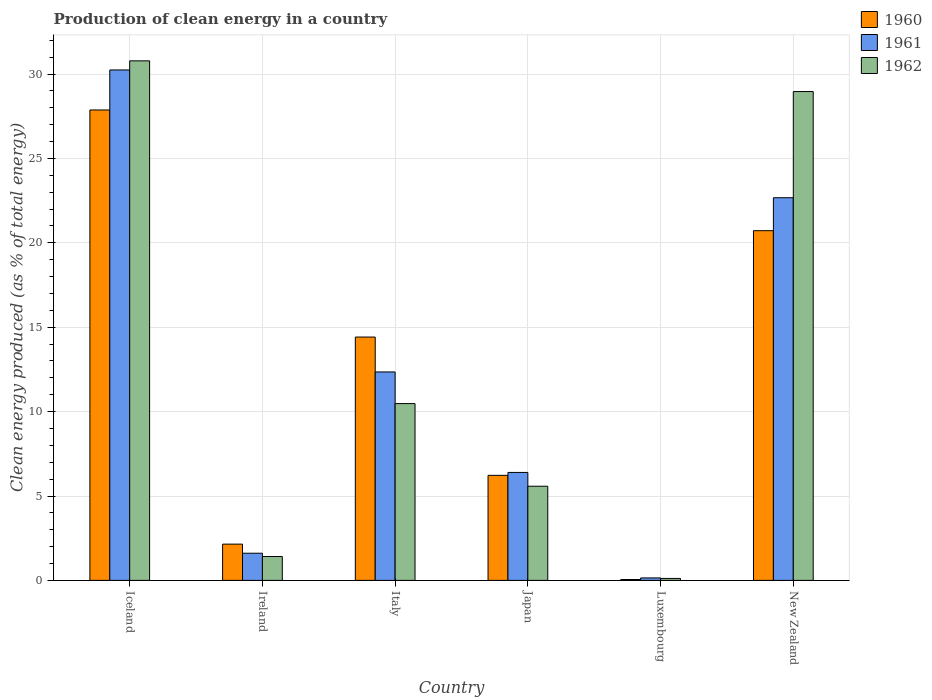How many groups of bars are there?
Provide a short and direct response. 6. Are the number of bars per tick equal to the number of legend labels?
Ensure brevity in your answer.  Yes. How many bars are there on the 4th tick from the left?
Provide a succinct answer. 3. What is the label of the 5th group of bars from the left?
Provide a short and direct response. Luxembourg. What is the percentage of clean energy produced in 1962 in Japan?
Offer a terse response. 5.58. Across all countries, what is the maximum percentage of clean energy produced in 1961?
Provide a succinct answer. 30.24. Across all countries, what is the minimum percentage of clean energy produced in 1960?
Your answer should be very brief. 0.05. In which country was the percentage of clean energy produced in 1960 maximum?
Provide a succinct answer. Iceland. In which country was the percentage of clean energy produced in 1960 minimum?
Keep it short and to the point. Luxembourg. What is the total percentage of clean energy produced in 1962 in the graph?
Your answer should be very brief. 77.33. What is the difference between the percentage of clean energy produced in 1962 in Luxembourg and that in New Zealand?
Provide a short and direct response. -28.85. What is the difference between the percentage of clean energy produced in 1961 in Iceland and the percentage of clean energy produced in 1962 in Ireland?
Ensure brevity in your answer.  28.83. What is the average percentage of clean energy produced in 1961 per country?
Provide a succinct answer. 12.24. What is the difference between the percentage of clean energy produced of/in 1960 and percentage of clean energy produced of/in 1961 in Italy?
Ensure brevity in your answer.  2.07. What is the ratio of the percentage of clean energy produced in 1960 in Ireland to that in Luxembourg?
Provide a short and direct response. 41.27. What is the difference between the highest and the second highest percentage of clean energy produced in 1960?
Make the answer very short. 7.15. What is the difference between the highest and the lowest percentage of clean energy produced in 1962?
Provide a short and direct response. 30.67. What does the 2nd bar from the left in Italy represents?
Provide a short and direct response. 1961. Are all the bars in the graph horizontal?
Make the answer very short. No. How many countries are there in the graph?
Offer a very short reply. 6. Does the graph contain grids?
Provide a short and direct response. Yes. Where does the legend appear in the graph?
Your answer should be compact. Top right. What is the title of the graph?
Ensure brevity in your answer.  Production of clean energy in a country. What is the label or title of the X-axis?
Ensure brevity in your answer.  Country. What is the label or title of the Y-axis?
Give a very brief answer. Clean energy produced (as % of total energy). What is the Clean energy produced (as % of total energy) of 1960 in Iceland?
Make the answer very short. 27.87. What is the Clean energy produced (as % of total energy) in 1961 in Iceland?
Your answer should be very brief. 30.24. What is the Clean energy produced (as % of total energy) in 1962 in Iceland?
Offer a very short reply. 30.78. What is the Clean energy produced (as % of total energy) in 1960 in Ireland?
Provide a succinct answer. 2.15. What is the Clean energy produced (as % of total energy) in 1961 in Ireland?
Make the answer very short. 1.61. What is the Clean energy produced (as % of total energy) of 1962 in Ireland?
Offer a very short reply. 1.41. What is the Clean energy produced (as % of total energy) in 1960 in Italy?
Provide a succinct answer. 14.42. What is the Clean energy produced (as % of total energy) in 1961 in Italy?
Provide a succinct answer. 12.35. What is the Clean energy produced (as % of total energy) of 1962 in Italy?
Provide a short and direct response. 10.48. What is the Clean energy produced (as % of total energy) in 1960 in Japan?
Your response must be concise. 6.22. What is the Clean energy produced (as % of total energy) in 1961 in Japan?
Keep it short and to the point. 6.4. What is the Clean energy produced (as % of total energy) in 1962 in Japan?
Make the answer very short. 5.58. What is the Clean energy produced (as % of total energy) of 1960 in Luxembourg?
Your answer should be compact. 0.05. What is the Clean energy produced (as % of total energy) in 1961 in Luxembourg?
Keep it short and to the point. 0.15. What is the Clean energy produced (as % of total energy) of 1962 in Luxembourg?
Your response must be concise. 0.12. What is the Clean energy produced (as % of total energy) of 1960 in New Zealand?
Ensure brevity in your answer.  20.72. What is the Clean energy produced (as % of total energy) of 1961 in New Zealand?
Offer a terse response. 22.67. What is the Clean energy produced (as % of total energy) in 1962 in New Zealand?
Offer a terse response. 28.96. Across all countries, what is the maximum Clean energy produced (as % of total energy) of 1960?
Offer a terse response. 27.87. Across all countries, what is the maximum Clean energy produced (as % of total energy) in 1961?
Keep it short and to the point. 30.24. Across all countries, what is the maximum Clean energy produced (as % of total energy) in 1962?
Provide a short and direct response. 30.78. Across all countries, what is the minimum Clean energy produced (as % of total energy) of 1960?
Your response must be concise. 0.05. Across all countries, what is the minimum Clean energy produced (as % of total energy) in 1961?
Make the answer very short. 0.15. Across all countries, what is the minimum Clean energy produced (as % of total energy) of 1962?
Keep it short and to the point. 0.12. What is the total Clean energy produced (as % of total energy) of 1960 in the graph?
Offer a terse response. 71.43. What is the total Clean energy produced (as % of total energy) of 1961 in the graph?
Your answer should be compact. 73.42. What is the total Clean energy produced (as % of total energy) in 1962 in the graph?
Your response must be concise. 77.33. What is the difference between the Clean energy produced (as % of total energy) of 1960 in Iceland and that in Ireland?
Make the answer very short. 25.72. What is the difference between the Clean energy produced (as % of total energy) of 1961 in Iceland and that in Ireland?
Offer a very short reply. 28.63. What is the difference between the Clean energy produced (as % of total energy) of 1962 in Iceland and that in Ireland?
Provide a short and direct response. 29.37. What is the difference between the Clean energy produced (as % of total energy) in 1960 in Iceland and that in Italy?
Make the answer very short. 13.46. What is the difference between the Clean energy produced (as % of total energy) in 1961 in Iceland and that in Italy?
Give a very brief answer. 17.89. What is the difference between the Clean energy produced (as % of total energy) in 1962 in Iceland and that in Italy?
Keep it short and to the point. 20.31. What is the difference between the Clean energy produced (as % of total energy) in 1960 in Iceland and that in Japan?
Your answer should be very brief. 21.65. What is the difference between the Clean energy produced (as % of total energy) of 1961 in Iceland and that in Japan?
Make the answer very short. 23.85. What is the difference between the Clean energy produced (as % of total energy) of 1962 in Iceland and that in Japan?
Your answer should be very brief. 25.2. What is the difference between the Clean energy produced (as % of total energy) in 1960 in Iceland and that in Luxembourg?
Offer a terse response. 27.82. What is the difference between the Clean energy produced (as % of total energy) of 1961 in Iceland and that in Luxembourg?
Your answer should be compact. 30.1. What is the difference between the Clean energy produced (as % of total energy) of 1962 in Iceland and that in Luxembourg?
Your answer should be very brief. 30.67. What is the difference between the Clean energy produced (as % of total energy) in 1960 in Iceland and that in New Zealand?
Provide a succinct answer. 7.15. What is the difference between the Clean energy produced (as % of total energy) of 1961 in Iceland and that in New Zealand?
Your response must be concise. 7.57. What is the difference between the Clean energy produced (as % of total energy) in 1962 in Iceland and that in New Zealand?
Provide a short and direct response. 1.82. What is the difference between the Clean energy produced (as % of total energy) of 1960 in Ireland and that in Italy?
Offer a very short reply. -12.27. What is the difference between the Clean energy produced (as % of total energy) in 1961 in Ireland and that in Italy?
Give a very brief answer. -10.74. What is the difference between the Clean energy produced (as % of total energy) in 1962 in Ireland and that in Italy?
Ensure brevity in your answer.  -9.06. What is the difference between the Clean energy produced (as % of total energy) in 1960 in Ireland and that in Japan?
Your answer should be compact. -4.08. What is the difference between the Clean energy produced (as % of total energy) of 1961 in Ireland and that in Japan?
Make the answer very short. -4.79. What is the difference between the Clean energy produced (as % of total energy) in 1962 in Ireland and that in Japan?
Give a very brief answer. -4.16. What is the difference between the Clean energy produced (as % of total energy) in 1960 in Ireland and that in Luxembourg?
Your response must be concise. 2.1. What is the difference between the Clean energy produced (as % of total energy) in 1961 in Ireland and that in Luxembourg?
Keep it short and to the point. 1.46. What is the difference between the Clean energy produced (as % of total energy) in 1962 in Ireland and that in Luxembourg?
Your answer should be compact. 1.3. What is the difference between the Clean energy produced (as % of total energy) in 1960 in Ireland and that in New Zealand?
Offer a very short reply. -18.57. What is the difference between the Clean energy produced (as % of total energy) of 1961 in Ireland and that in New Zealand?
Your response must be concise. -21.06. What is the difference between the Clean energy produced (as % of total energy) in 1962 in Ireland and that in New Zealand?
Your answer should be compact. -27.55. What is the difference between the Clean energy produced (as % of total energy) in 1960 in Italy and that in Japan?
Offer a terse response. 8.19. What is the difference between the Clean energy produced (as % of total energy) in 1961 in Italy and that in Japan?
Provide a succinct answer. 5.95. What is the difference between the Clean energy produced (as % of total energy) in 1962 in Italy and that in Japan?
Your answer should be compact. 4.9. What is the difference between the Clean energy produced (as % of total energy) of 1960 in Italy and that in Luxembourg?
Your answer should be very brief. 14.37. What is the difference between the Clean energy produced (as % of total energy) in 1961 in Italy and that in Luxembourg?
Give a very brief answer. 12.2. What is the difference between the Clean energy produced (as % of total energy) of 1962 in Italy and that in Luxembourg?
Your response must be concise. 10.36. What is the difference between the Clean energy produced (as % of total energy) in 1960 in Italy and that in New Zealand?
Your answer should be very brief. -6.3. What is the difference between the Clean energy produced (as % of total energy) in 1961 in Italy and that in New Zealand?
Keep it short and to the point. -10.32. What is the difference between the Clean energy produced (as % of total energy) of 1962 in Italy and that in New Zealand?
Give a very brief answer. -18.49. What is the difference between the Clean energy produced (as % of total energy) of 1960 in Japan and that in Luxembourg?
Offer a terse response. 6.17. What is the difference between the Clean energy produced (as % of total energy) of 1961 in Japan and that in Luxembourg?
Offer a very short reply. 6.25. What is the difference between the Clean energy produced (as % of total energy) of 1962 in Japan and that in Luxembourg?
Offer a very short reply. 5.46. What is the difference between the Clean energy produced (as % of total energy) in 1960 in Japan and that in New Zealand?
Offer a terse response. -14.5. What is the difference between the Clean energy produced (as % of total energy) of 1961 in Japan and that in New Zealand?
Keep it short and to the point. -16.28. What is the difference between the Clean energy produced (as % of total energy) in 1962 in Japan and that in New Zealand?
Provide a short and direct response. -23.38. What is the difference between the Clean energy produced (as % of total energy) in 1960 in Luxembourg and that in New Zealand?
Provide a short and direct response. -20.67. What is the difference between the Clean energy produced (as % of total energy) in 1961 in Luxembourg and that in New Zealand?
Your answer should be compact. -22.53. What is the difference between the Clean energy produced (as % of total energy) of 1962 in Luxembourg and that in New Zealand?
Your answer should be very brief. -28.85. What is the difference between the Clean energy produced (as % of total energy) of 1960 in Iceland and the Clean energy produced (as % of total energy) of 1961 in Ireland?
Your answer should be compact. 26.26. What is the difference between the Clean energy produced (as % of total energy) in 1960 in Iceland and the Clean energy produced (as % of total energy) in 1962 in Ireland?
Provide a short and direct response. 26.46. What is the difference between the Clean energy produced (as % of total energy) in 1961 in Iceland and the Clean energy produced (as % of total energy) in 1962 in Ireland?
Offer a very short reply. 28.83. What is the difference between the Clean energy produced (as % of total energy) of 1960 in Iceland and the Clean energy produced (as % of total energy) of 1961 in Italy?
Ensure brevity in your answer.  15.52. What is the difference between the Clean energy produced (as % of total energy) of 1960 in Iceland and the Clean energy produced (as % of total energy) of 1962 in Italy?
Provide a short and direct response. 17.4. What is the difference between the Clean energy produced (as % of total energy) of 1961 in Iceland and the Clean energy produced (as % of total energy) of 1962 in Italy?
Your answer should be compact. 19.77. What is the difference between the Clean energy produced (as % of total energy) in 1960 in Iceland and the Clean energy produced (as % of total energy) in 1961 in Japan?
Your answer should be very brief. 21.48. What is the difference between the Clean energy produced (as % of total energy) of 1960 in Iceland and the Clean energy produced (as % of total energy) of 1962 in Japan?
Ensure brevity in your answer.  22.29. What is the difference between the Clean energy produced (as % of total energy) in 1961 in Iceland and the Clean energy produced (as % of total energy) in 1962 in Japan?
Make the answer very short. 24.66. What is the difference between the Clean energy produced (as % of total energy) in 1960 in Iceland and the Clean energy produced (as % of total energy) in 1961 in Luxembourg?
Provide a succinct answer. 27.73. What is the difference between the Clean energy produced (as % of total energy) of 1960 in Iceland and the Clean energy produced (as % of total energy) of 1962 in Luxembourg?
Provide a short and direct response. 27.76. What is the difference between the Clean energy produced (as % of total energy) of 1961 in Iceland and the Clean energy produced (as % of total energy) of 1962 in Luxembourg?
Provide a short and direct response. 30.13. What is the difference between the Clean energy produced (as % of total energy) of 1960 in Iceland and the Clean energy produced (as % of total energy) of 1961 in New Zealand?
Your answer should be compact. 5.2. What is the difference between the Clean energy produced (as % of total energy) of 1960 in Iceland and the Clean energy produced (as % of total energy) of 1962 in New Zealand?
Make the answer very short. -1.09. What is the difference between the Clean energy produced (as % of total energy) of 1961 in Iceland and the Clean energy produced (as % of total energy) of 1962 in New Zealand?
Provide a succinct answer. 1.28. What is the difference between the Clean energy produced (as % of total energy) in 1960 in Ireland and the Clean energy produced (as % of total energy) in 1961 in Italy?
Make the answer very short. -10.2. What is the difference between the Clean energy produced (as % of total energy) in 1960 in Ireland and the Clean energy produced (as % of total energy) in 1962 in Italy?
Your answer should be very brief. -8.33. What is the difference between the Clean energy produced (as % of total energy) of 1961 in Ireland and the Clean energy produced (as % of total energy) of 1962 in Italy?
Your answer should be very brief. -8.87. What is the difference between the Clean energy produced (as % of total energy) in 1960 in Ireland and the Clean energy produced (as % of total energy) in 1961 in Japan?
Offer a very short reply. -4.25. What is the difference between the Clean energy produced (as % of total energy) in 1960 in Ireland and the Clean energy produced (as % of total energy) in 1962 in Japan?
Offer a terse response. -3.43. What is the difference between the Clean energy produced (as % of total energy) of 1961 in Ireland and the Clean energy produced (as % of total energy) of 1962 in Japan?
Your response must be concise. -3.97. What is the difference between the Clean energy produced (as % of total energy) of 1960 in Ireland and the Clean energy produced (as % of total energy) of 1961 in Luxembourg?
Make the answer very short. 2. What is the difference between the Clean energy produced (as % of total energy) of 1960 in Ireland and the Clean energy produced (as % of total energy) of 1962 in Luxembourg?
Offer a terse response. 2.03. What is the difference between the Clean energy produced (as % of total energy) of 1961 in Ireland and the Clean energy produced (as % of total energy) of 1962 in Luxembourg?
Provide a short and direct response. 1.49. What is the difference between the Clean energy produced (as % of total energy) in 1960 in Ireland and the Clean energy produced (as % of total energy) in 1961 in New Zealand?
Keep it short and to the point. -20.52. What is the difference between the Clean energy produced (as % of total energy) of 1960 in Ireland and the Clean energy produced (as % of total energy) of 1962 in New Zealand?
Make the answer very short. -26.82. What is the difference between the Clean energy produced (as % of total energy) of 1961 in Ireland and the Clean energy produced (as % of total energy) of 1962 in New Zealand?
Provide a short and direct response. -27.35. What is the difference between the Clean energy produced (as % of total energy) of 1960 in Italy and the Clean energy produced (as % of total energy) of 1961 in Japan?
Your answer should be compact. 8.02. What is the difference between the Clean energy produced (as % of total energy) in 1960 in Italy and the Clean energy produced (as % of total energy) in 1962 in Japan?
Offer a very short reply. 8.84. What is the difference between the Clean energy produced (as % of total energy) of 1961 in Italy and the Clean energy produced (as % of total energy) of 1962 in Japan?
Offer a very short reply. 6.77. What is the difference between the Clean energy produced (as % of total energy) in 1960 in Italy and the Clean energy produced (as % of total energy) in 1961 in Luxembourg?
Make the answer very short. 14.27. What is the difference between the Clean energy produced (as % of total energy) of 1960 in Italy and the Clean energy produced (as % of total energy) of 1962 in Luxembourg?
Offer a terse response. 14.3. What is the difference between the Clean energy produced (as % of total energy) in 1961 in Italy and the Clean energy produced (as % of total energy) in 1962 in Luxembourg?
Offer a very short reply. 12.23. What is the difference between the Clean energy produced (as % of total energy) of 1960 in Italy and the Clean energy produced (as % of total energy) of 1961 in New Zealand?
Make the answer very short. -8.26. What is the difference between the Clean energy produced (as % of total energy) of 1960 in Italy and the Clean energy produced (as % of total energy) of 1962 in New Zealand?
Your response must be concise. -14.55. What is the difference between the Clean energy produced (as % of total energy) in 1961 in Italy and the Clean energy produced (as % of total energy) in 1962 in New Zealand?
Ensure brevity in your answer.  -16.61. What is the difference between the Clean energy produced (as % of total energy) of 1960 in Japan and the Clean energy produced (as % of total energy) of 1961 in Luxembourg?
Ensure brevity in your answer.  6.08. What is the difference between the Clean energy produced (as % of total energy) of 1960 in Japan and the Clean energy produced (as % of total energy) of 1962 in Luxembourg?
Ensure brevity in your answer.  6.11. What is the difference between the Clean energy produced (as % of total energy) in 1961 in Japan and the Clean energy produced (as % of total energy) in 1962 in Luxembourg?
Your answer should be compact. 6.28. What is the difference between the Clean energy produced (as % of total energy) in 1960 in Japan and the Clean energy produced (as % of total energy) in 1961 in New Zealand?
Offer a very short reply. -16.45. What is the difference between the Clean energy produced (as % of total energy) in 1960 in Japan and the Clean energy produced (as % of total energy) in 1962 in New Zealand?
Provide a short and direct response. -22.74. What is the difference between the Clean energy produced (as % of total energy) of 1961 in Japan and the Clean energy produced (as % of total energy) of 1962 in New Zealand?
Make the answer very short. -22.57. What is the difference between the Clean energy produced (as % of total energy) of 1960 in Luxembourg and the Clean energy produced (as % of total energy) of 1961 in New Zealand?
Give a very brief answer. -22.62. What is the difference between the Clean energy produced (as % of total energy) of 1960 in Luxembourg and the Clean energy produced (as % of total energy) of 1962 in New Zealand?
Keep it short and to the point. -28.91. What is the difference between the Clean energy produced (as % of total energy) of 1961 in Luxembourg and the Clean energy produced (as % of total energy) of 1962 in New Zealand?
Make the answer very short. -28.82. What is the average Clean energy produced (as % of total energy) in 1960 per country?
Provide a succinct answer. 11.91. What is the average Clean energy produced (as % of total energy) in 1961 per country?
Your answer should be very brief. 12.24. What is the average Clean energy produced (as % of total energy) of 1962 per country?
Your answer should be very brief. 12.89. What is the difference between the Clean energy produced (as % of total energy) of 1960 and Clean energy produced (as % of total energy) of 1961 in Iceland?
Give a very brief answer. -2.37. What is the difference between the Clean energy produced (as % of total energy) in 1960 and Clean energy produced (as % of total energy) in 1962 in Iceland?
Offer a very short reply. -2.91. What is the difference between the Clean energy produced (as % of total energy) of 1961 and Clean energy produced (as % of total energy) of 1962 in Iceland?
Ensure brevity in your answer.  -0.54. What is the difference between the Clean energy produced (as % of total energy) of 1960 and Clean energy produced (as % of total energy) of 1961 in Ireland?
Offer a terse response. 0.54. What is the difference between the Clean energy produced (as % of total energy) of 1960 and Clean energy produced (as % of total energy) of 1962 in Ireland?
Your answer should be compact. 0.73. What is the difference between the Clean energy produced (as % of total energy) of 1961 and Clean energy produced (as % of total energy) of 1962 in Ireland?
Offer a very short reply. 0.19. What is the difference between the Clean energy produced (as % of total energy) of 1960 and Clean energy produced (as % of total energy) of 1961 in Italy?
Ensure brevity in your answer.  2.07. What is the difference between the Clean energy produced (as % of total energy) in 1960 and Clean energy produced (as % of total energy) in 1962 in Italy?
Your answer should be very brief. 3.94. What is the difference between the Clean energy produced (as % of total energy) in 1961 and Clean energy produced (as % of total energy) in 1962 in Italy?
Offer a very short reply. 1.87. What is the difference between the Clean energy produced (as % of total energy) of 1960 and Clean energy produced (as % of total energy) of 1961 in Japan?
Your answer should be compact. -0.17. What is the difference between the Clean energy produced (as % of total energy) in 1960 and Clean energy produced (as % of total energy) in 1962 in Japan?
Your answer should be compact. 0.64. What is the difference between the Clean energy produced (as % of total energy) of 1961 and Clean energy produced (as % of total energy) of 1962 in Japan?
Offer a terse response. 0.82. What is the difference between the Clean energy produced (as % of total energy) of 1960 and Clean energy produced (as % of total energy) of 1961 in Luxembourg?
Provide a succinct answer. -0.09. What is the difference between the Clean energy produced (as % of total energy) of 1960 and Clean energy produced (as % of total energy) of 1962 in Luxembourg?
Offer a terse response. -0.06. What is the difference between the Clean energy produced (as % of total energy) of 1961 and Clean energy produced (as % of total energy) of 1962 in Luxembourg?
Offer a terse response. 0.03. What is the difference between the Clean energy produced (as % of total energy) in 1960 and Clean energy produced (as % of total energy) in 1961 in New Zealand?
Your answer should be compact. -1.95. What is the difference between the Clean energy produced (as % of total energy) in 1960 and Clean energy produced (as % of total energy) in 1962 in New Zealand?
Provide a short and direct response. -8.24. What is the difference between the Clean energy produced (as % of total energy) in 1961 and Clean energy produced (as % of total energy) in 1962 in New Zealand?
Offer a very short reply. -6.29. What is the ratio of the Clean energy produced (as % of total energy) of 1960 in Iceland to that in Ireland?
Your answer should be compact. 12.97. What is the ratio of the Clean energy produced (as % of total energy) of 1961 in Iceland to that in Ireland?
Ensure brevity in your answer.  18.79. What is the ratio of the Clean energy produced (as % of total energy) of 1962 in Iceland to that in Ireland?
Ensure brevity in your answer.  21.76. What is the ratio of the Clean energy produced (as % of total energy) of 1960 in Iceland to that in Italy?
Keep it short and to the point. 1.93. What is the ratio of the Clean energy produced (as % of total energy) in 1961 in Iceland to that in Italy?
Give a very brief answer. 2.45. What is the ratio of the Clean energy produced (as % of total energy) of 1962 in Iceland to that in Italy?
Your answer should be compact. 2.94. What is the ratio of the Clean energy produced (as % of total energy) in 1960 in Iceland to that in Japan?
Offer a terse response. 4.48. What is the ratio of the Clean energy produced (as % of total energy) in 1961 in Iceland to that in Japan?
Your answer should be very brief. 4.73. What is the ratio of the Clean energy produced (as % of total energy) in 1962 in Iceland to that in Japan?
Your response must be concise. 5.52. What is the ratio of the Clean energy produced (as % of total energy) of 1960 in Iceland to that in Luxembourg?
Your answer should be very brief. 535.41. What is the ratio of the Clean energy produced (as % of total energy) in 1961 in Iceland to that in Luxembourg?
Your answer should be compact. 205.92. What is the ratio of the Clean energy produced (as % of total energy) in 1962 in Iceland to that in Luxembourg?
Offer a very short reply. 265.71. What is the ratio of the Clean energy produced (as % of total energy) of 1960 in Iceland to that in New Zealand?
Offer a terse response. 1.35. What is the ratio of the Clean energy produced (as % of total energy) of 1961 in Iceland to that in New Zealand?
Provide a short and direct response. 1.33. What is the ratio of the Clean energy produced (as % of total energy) in 1962 in Iceland to that in New Zealand?
Provide a short and direct response. 1.06. What is the ratio of the Clean energy produced (as % of total energy) of 1960 in Ireland to that in Italy?
Give a very brief answer. 0.15. What is the ratio of the Clean energy produced (as % of total energy) in 1961 in Ireland to that in Italy?
Offer a terse response. 0.13. What is the ratio of the Clean energy produced (as % of total energy) of 1962 in Ireland to that in Italy?
Ensure brevity in your answer.  0.14. What is the ratio of the Clean energy produced (as % of total energy) in 1960 in Ireland to that in Japan?
Your response must be concise. 0.35. What is the ratio of the Clean energy produced (as % of total energy) of 1961 in Ireland to that in Japan?
Your answer should be very brief. 0.25. What is the ratio of the Clean energy produced (as % of total energy) of 1962 in Ireland to that in Japan?
Your response must be concise. 0.25. What is the ratio of the Clean energy produced (as % of total energy) in 1960 in Ireland to that in Luxembourg?
Make the answer very short. 41.27. What is the ratio of the Clean energy produced (as % of total energy) in 1961 in Ireland to that in Luxembourg?
Your response must be concise. 10.96. What is the ratio of the Clean energy produced (as % of total energy) of 1962 in Ireland to that in Luxembourg?
Offer a very short reply. 12.21. What is the ratio of the Clean energy produced (as % of total energy) of 1960 in Ireland to that in New Zealand?
Ensure brevity in your answer.  0.1. What is the ratio of the Clean energy produced (as % of total energy) in 1961 in Ireland to that in New Zealand?
Your answer should be compact. 0.07. What is the ratio of the Clean energy produced (as % of total energy) of 1962 in Ireland to that in New Zealand?
Make the answer very short. 0.05. What is the ratio of the Clean energy produced (as % of total energy) in 1960 in Italy to that in Japan?
Offer a terse response. 2.32. What is the ratio of the Clean energy produced (as % of total energy) in 1961 in Italy to that in Japan?
Your answer should be compact. 1.93. What is the ratio of the Clean energy produced (as % of total energy) of 1962 in Italy to that in Japan?
Provide a short and direct response. 1.88. What is the ratio of the Clean energy produced (as % of total energy) in 1960 in Italy to that in Luxembourg?
Your answer should be very brief. 276.95. What is the ratio of the Clean energy produced (as % of total energy) of 1961 in Italy to that in Luxembourg?
Give a very brief answer. 84.09. What is the ratio of the Clean energy produced (as % of total energy) of 1962 in Italy to that in Luxembourg?
Provide a succinct answer. 90.43. What is the ratio of the Clean energy produced (as % of total energy) of 1960 in Italy to that in New Zealand?
Your answer should be compact. 0.7. What is the ratio of the Clean energy produced (as % of total energy) in 1961 in Italy to that in New Zealand?
Provide a short and direct response. 0.54. What is the ratio of the Clean energy produced (as % of total energy) in 1962 in Italy to that in New Zealand?
Ensure brevity in your answer.  0.36. What is the ratio of the Clean energy produced (as % of total energy) in 1960 in Japan to that in Luxembourg?
Your response must be concise. 119.55. What is the ratio of the Clean energy produced (as % of total energy) of 1961 in Japan to that in Luxembourg?
Provide a succinct answer. 43.55. What is the ratio of the Clean energy produced (as % of total energy) of 1962 in Japan to that in Luxembourg?
Provide a short and direct response. 48.16. What is the ratio of the Clean energy produced (as % of total energy) of 1960 in Japan to that in New Zealand?
Offer a very short reply. 0.3. What is the ratio of the Clean energy produced (as % of total energy) in 1961 in Japan to that in New Zealand?
Provide a succinct answer. 0.28. What is the ratio of the Clean energy produced (as % of total energy) of 1962 in Japan to that in New Zealand?
Offer a very short reply. 0.19. What is the ratio of the Clean energy produced (as % of total energy) in 1960 in Luxembourg to that in New Zealand?
Make the answer very short. 0. What is the ratio of the Clean energy produced (as % of total energy) in 1961 in Luxembourg to that in New Zealand?
Give a very brief answer. 0.01. What is the ratio of the Clean energy produced (as % of total energy) in 1962 in Luxembourg to that in New Zealand?
Offer a terse response. 0. What is the difference between the highest and the second highest Clean energy produced (as % of total energy) in 1960?
Offer a terse response. 7.15. What is the difference between the highest and the second highest Clean energy produced (as % of total energy) of 1961?
Keep it short and to the point. 7.57. What is the difference between the highest and the second highest Clean energy produced (as % of total energy) in 1962?
Keep it short and to the point. 1.82. What is the difference between the highest and the lowest Clean energy produced (as % of total energy) of 1960?
Provide a succinct answer. 27.82. What is the difference between the highest and the lowest Clean energy produced (as % of total energy) of 1961?
Make the answer very short. 30.1. What is the difference between the highest and the lowest Clean energy produced (as % of total energy) of 1962?
Provide a succinct answer. 30.67. 